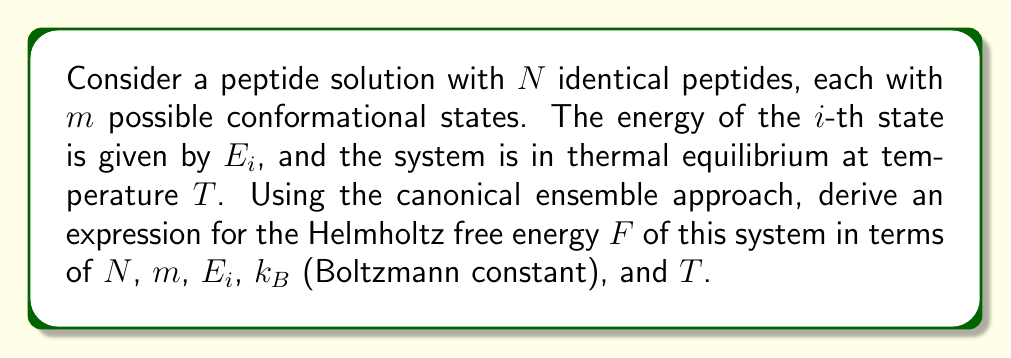Could you help me with this problem? 1. Start with the partition function $Z$ for a single peptide:
   $$Z = \sum_{i=1}^m e^{-\beta E_i}$$
   where $\beta = \frac{1}{k_B T}$

2. For $N$ identical and independent peptides, the total partition function $Z_N$ is:
   $$Z_N = Z^N = \left(\sum_{i=1}^m e^{-\beta E_i}\right)^N$$

3. The Helmholtz free energy $F$ is related to the partition function by:
   $$F = -k_B T \ln Z_N$$

4. Substitute $Z_N$ into the free energy equation:
   $$F = -k_B T \ln \left(\sum_{i=1}^m e^{-\beta E_i}\right)^N$$

5. Use the properties of logarithms to simplify:
   $$F = -N k_B T \ln \left(\sum_{i=1}^m e^{-\beta E_i}\right)$$

6. This is the final expression for the Helmholtz free energy of the peptide solution.
Answer: $F = -N k_B T \ln \left(\sum_{i=1}^m e^{-E_i/(k_B T)}\right)$ 